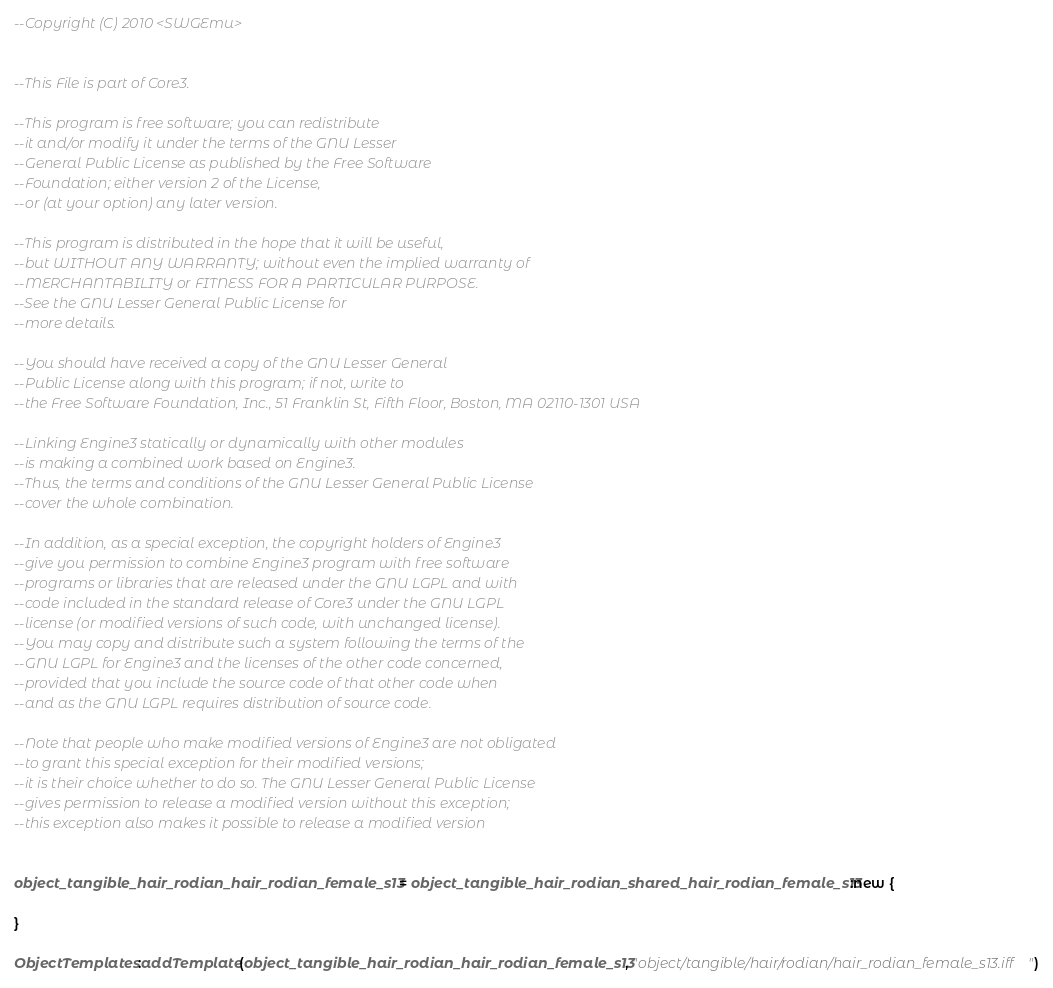<code> <loc_0><loc_0><loc_500><loc_500><_Lua_>--Copyright (C) 2010 <SWGEmu>


--This File is part of Core3.

--This program is free software; you can redistribute 
--it and/or modify it under the terms of the GNU Lesser 
--General Public License as published by the Free Software
--Foundation; either version 2 of the License, 
--or (at your option) any later version.

--This program is distributed in the hope that it will be useful, 
--but WITHOUT ANY WARRANTY; without even the implied warranty of 
--MERCHANTABILITY or FITNESS FOR A PARTICULAR PURPOSE. 
--See the GNU Lesser General Public License for
--more details.

--You should have received a copy of the GNU Lesser General 
--Public License along with this program; if not, write to
--the Free Software Foundation, Inc., 51 Franklin St, Fifth Floor, Boston, MA 02110-1301 USA

--Linking Engine3 statically or dynamically with other modules 
--is making a combined work based on Engine3. 
--Thus, the terms and conditions of the GNU Lesser General Public License 
--cover the whole combination.

--In addition, as a special exception, the copyright holders of Engine3 
--give you permission to combine Engine3 program with free software 
--programs or libraries that are released under the GNU LGPL and with 
--code included in the standard release of Core3 under the GNU LGPL 
--license (or modified versions of such code, with unchanged license). 
--You may copy and distribute such a system following the terms of the 
--GNU LGPL for Engine3 and the licenses of the other code concerned, 
--provided that you include the source code of that other code when 
--and as the GNU LGPL requires distribution of source code.

--Note that people who make modified versions of Engine3 are not obligated 
--to grant this special exception for their modified versions; 
--it is their choice whether to do so. The GNU Lesser General Public License 
--gives permission to release a modified version without this exception; 
--this exception also makes it possible to release a modified version 


object_tangible_hair_rodian_hair_rodian_female_s13 = object_tangible_hair_rodian_shared_hair_rodian_female_s13:new {

}

ObjectTemplates:addTemplate(object_tangible_hair_rodian_hair_rodian_female_s13, "object/tangible/hair/rodian/hair_rodian_female_s13.iff")
</code> 